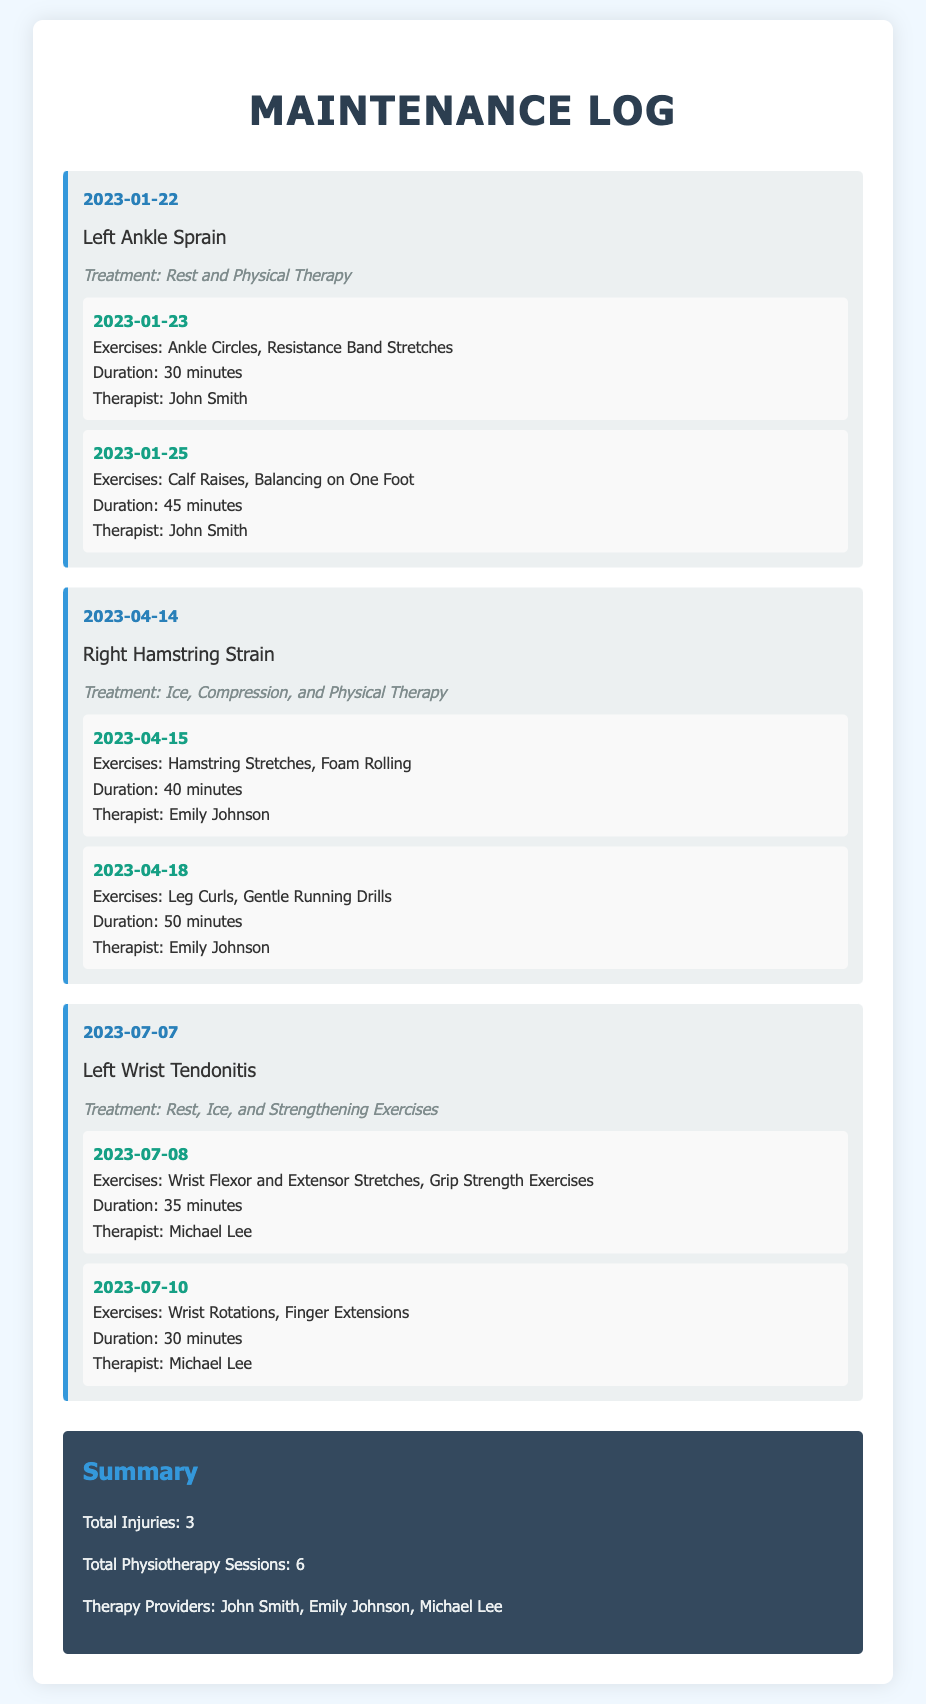what is the date of the first injury? The first injury recorded is the Left Ankle Sprain which occurred on January 22, 2023.
Answer: January 22, 2023 who treated the Right Hamstring Strain? The Right Hamstring Strain was treated by Emily Johnson as indicated in the document.
Answer: Emily Johnson how many total physiotherapy sessions are recorded? The document states that there are a total of 6 physiotherapy sessions across all injuries.
Answer: 6 what exercises were done in the physiotherapy session on April 15, 2023? The physiotherapy session on April 15, 2023, included Hamstring Stretches and Foam Rolling.
Answer: Hamstring Stretches, Foam Rolling which therapist provided treatment for the Left Wrist Tendonitis? Michael Lee is the therapist who provided treatment for the Left Wrist Tendonitis.
Answer: Michael Lee what is the total number of injuries listed in the summary? The summary in the document indicates that there are 3 injuries.
Answer: 3 what treatment was given for the Left Ankle Sprain? The treatment for the Left Ankle Sprain included Rest and Physical Therapy.
Answer: Rest and Physical Therapy which injury occurred on July 7, 2023? The injury that occurred on July 7, 2023, is the Left Wrist Tendonitis.
Answer: Left Wrist Tendonitis how long was the physiotherapy session on January 25, 2023? The physiotherapy session on January 25, 2023, lasted for 45 minutes.
Answer: 45 minutes 